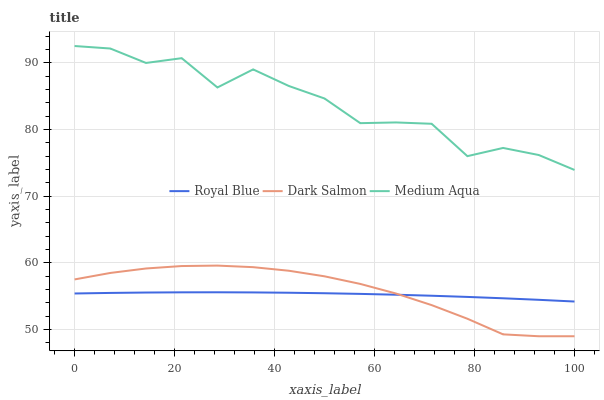Does Royal Blue have the minimum area under the curve?
Answer yes or no. Yes. Does Medium Aqua have the maximum area under the curve?
Answer yes or no. Yes. Does Dark Salmon have the minimum area under the curve?
Answer yes or no. No. Does Dark Salmon have the maximum area under the curve?
Answer yes or no. No. Is Royal Blue the smoothest?
Answer yes or no. Yes. Is Medium Aqua the roughest?
Answer yes or no. Yes. Is Dark Salmon the smoothest?
Answer yes or no. No. Is Dark Salmon the roughest?
Answer yes or no. No. Does Medium Aqua have the lowest value?
Answer yes or no. No. Does Dark Salmon have the highest value?
Answer yes or no. No. Is Dark Salmon less than Medium Aqua?
Answer yes or no. Yes. Is Medium Aqua greater than Dark Salmon?
Answer yes or no. Yes. Does Dark Salmon intersect Medium Aqua?
Answer yes or no. No. 